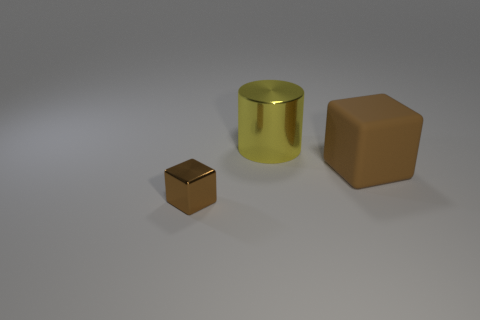Add 2 small rubber cylinders. How many objects exist? 5 Subtract all cubes. How many objects are left? 1 Add 3 large yellow cylinders. How many large yellow cylinders are left? 4 Add 1 large rubber things. How many large rubber things exist? 2 Subtract 0 purple cubes. How many objects are left? 3 Subtract all large brown rubber things. Subtract all big metallic things. How many objects are left? 1 